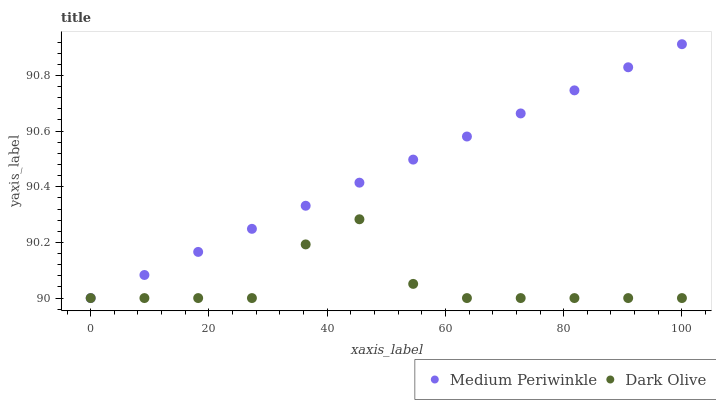Does Dark Olive have the minimum area under the curve?
Answer yes or no. Yes. Does Medium Periwinkle have the maximum area under the curve?
Answer yes or no. Yes. Does Medium Periwinkle have the minimum area under the curve?
Answer yes or no. No. Is Medium Periwinkle the smoothest?
Answer yes or no. Yes. Is Dark Olive the roughest?
Answer yes or no. Yes. Is Medium Periwinkle the roughest?
Answer yes or no. No. Does Dark Olive have the lowest value?
Answer yes or no. Yes. Does Medium Periwinkle have the highest value?
Answer yes or no. Yes. Does Dark Olive intersect Medium Periwinkle?
Answer yes or no. Yes. Is Dark Olive less than Medium Periwinkle?
Answer yes or no. No. Is Dark Olive greater than Medium Periwinkle?
Answer yes or no. No. 